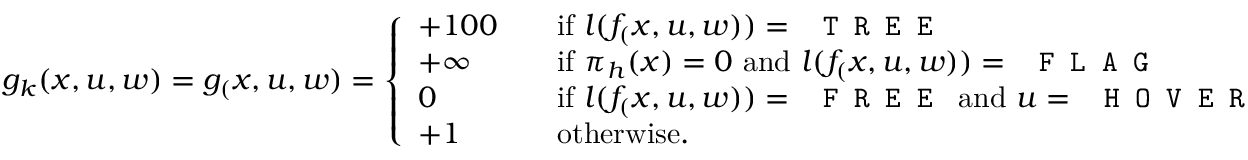<formula> <loc_0><loc_0><loc_500><loc_500>g _ { k } ( x , u , w ) = g _ { ( } x , u , w ) = \left \{ \begin{array} { l l } { + 1 0 0 \quad } & { i f l ( f _ { ( } x , u , w ) ) = T R E E } \\ { + \infty } & { i f \pi _ { h } ( x ) = 0 a n d l ( f _ { ( } x , u , w ) ) = F L A G } \\ { 0 } & { i f l ( f _ { ( } x , u , w ) ) = F R E E a n d u = H O V E R } \\ { + 1 } & { o t h e r w i s e . } \end{array}</formula> 